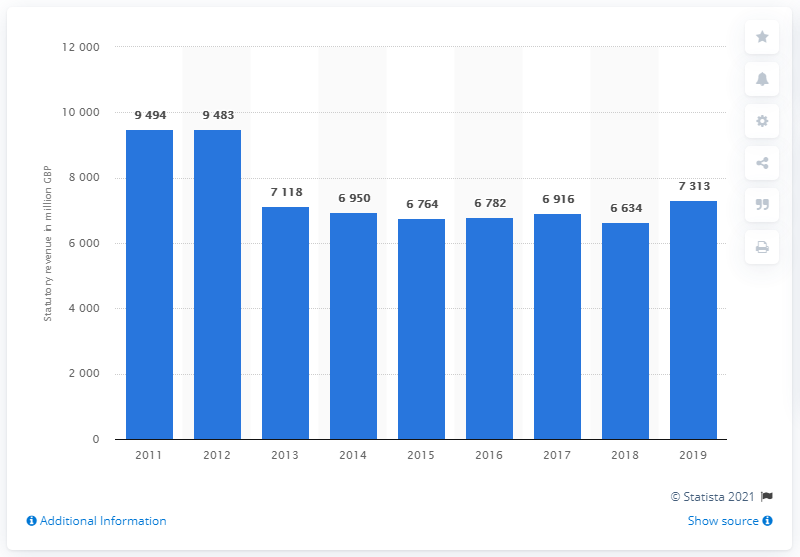Specify some key components in this picture. The revenue of the Balfour Beatty group fluctuated between 9,483 million euros and 10,233 million euros from 2011 to 2019. 